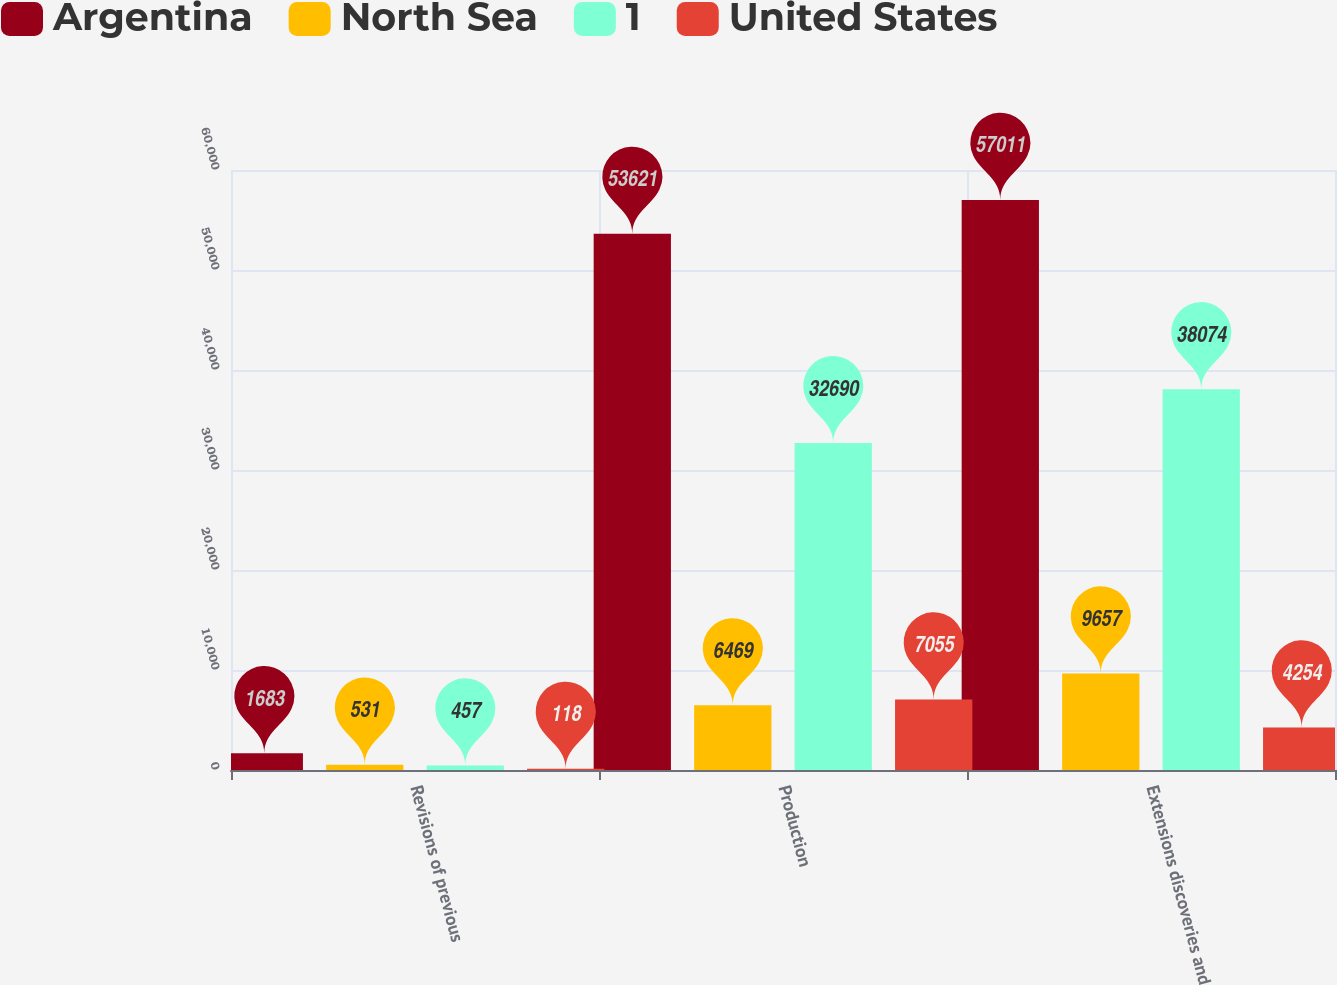Convert chart to OTSL. <chart><loc_0><loc_0><loc_500><loc_500><stacked_bar_chart><ecel><fcel>Revisions of previous<fcel>Production<fcel>Extensions discoveries and<nl><fcel>Argentina<fcel>1683<fcel>53621<fcel>57011<nl><fcel>North Sea<fcel>531<fcel>6469<fcel>9657<nl><fcel>1<fcel>457<fcel>32690<fcel>38074<nl><fcel>United States<fcel>118<fcel>7055<fcel>4254<nl></chart> 